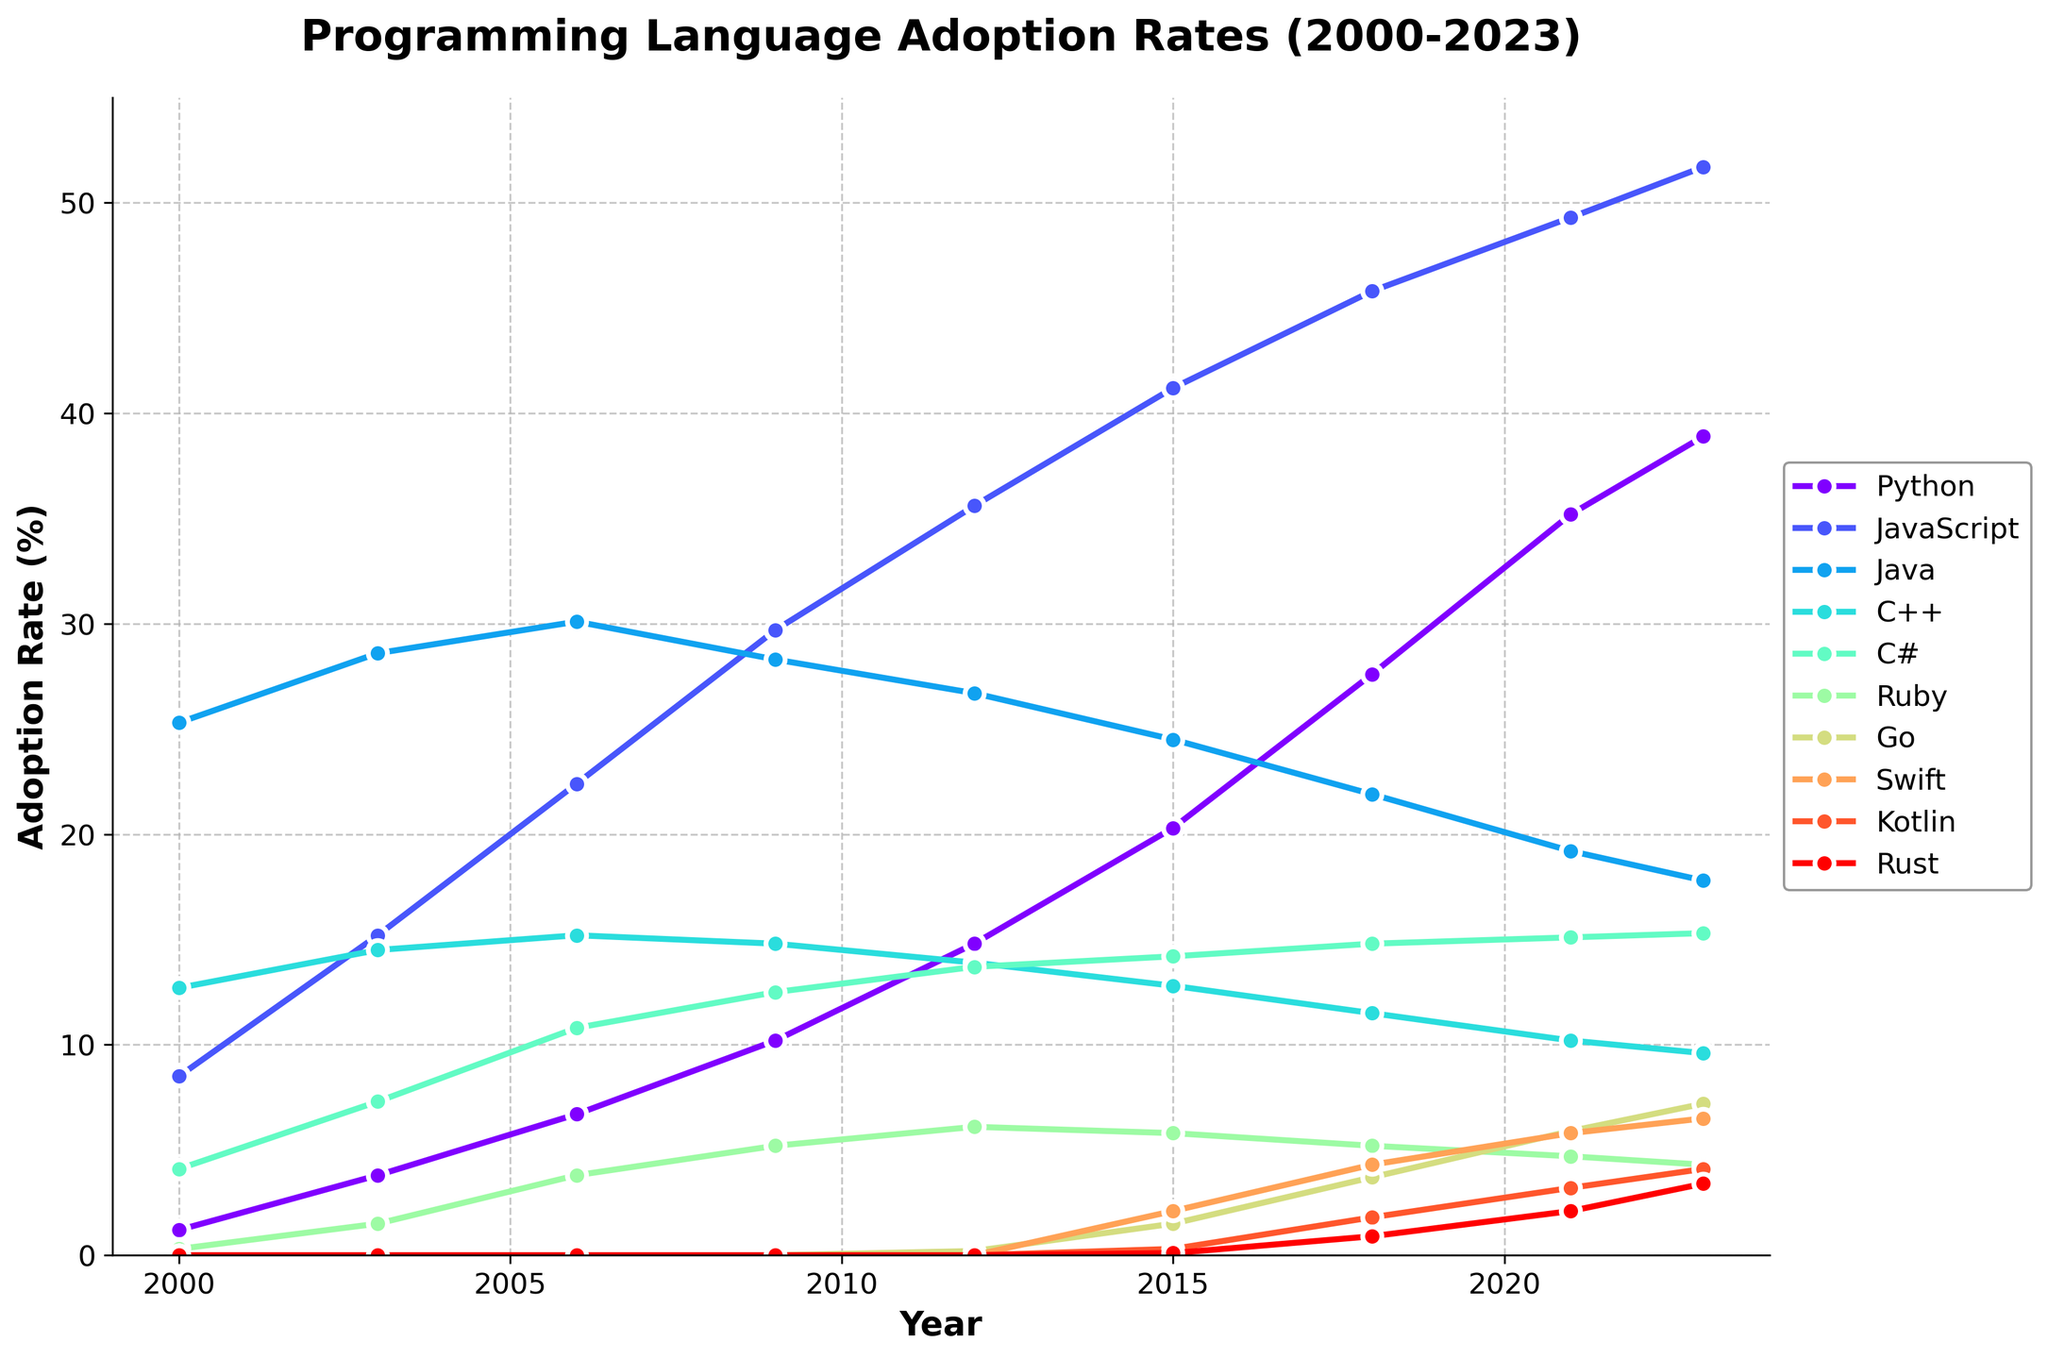What is the adoption rate of Python and JavaScript in 2023? The figure shows the adoption rates at different years. Looking specifically at the year 2023 for Python, the line intersects the y-axis at around 38.9. For JavaScript, the line intersects the y-axis at around 51.7
Answer: Python: 38.9, JavaScript: 51.7 How has the adoption rate of Java changed from 2000 to 2023? Refer to the figure at two points: 2000 and 2023. In 2000, Java adoption was approximately 25.3. By 2023, it declined to around 17.8. The difference is 25.3 - 17.8
Answer: Decreased by 7.5 Which year shows the greatest increase in Python adoption rate? By comparing the slopes of the Python line between different years, the steepest rise will indicate the greatest increase. From the visual, the largest jump occurs between 2009 and 2012 (from 10.2% to 14.8%). The increase is 14.8 - 10.2
Answer: Between 2009 and 2012 What is the trend of C++ adoption rate over the years? Observe the C++ line which starts at 12.7% in 2000, rises slightly to a peak around 2006 (15.2%), and then steadily declines to 9.6% in 2023. The overall trend shows an initial rise followed by a consistent decline
Answer: Initially increased, then steadily declined Compare the adoption rates of Swift and Kotlin in 2023. Which one is higher and by how much? In 2023, the figure shows Swift at approximately 6.5% and Kotlin at 4.1%. The difference is 6.5 - 4.1
Answer: Swift is higher by 2.4 Which programming language showed the least adoption rate in 2023? By comparing the y-values for the year 2023, Ruby has the lowest adoption rate of approximately 4.3%
Answer: Ruby with 4.3 Calculate the average adoption rate of Rust from 2000 to 2023. Rust adoption is only shown starting from 2018 (0.9%), 2021 (2.1%), and 2023 (3.4%). The average is calculated as (0.9 + 2.1 + 3.4) / 3
Answer: 2.13 How does the adoption rate of C# in 2023 compare to that in 2003? C# adoption in 2003 is about 7.3%, rising to around 15.3% in 2023. Therefore, the rate more than doubled
Answer: More than doubled Identify the programming language with the most stable adoption rate between 2000 and 2023. Reviewing the figure, C++ displays the least variance compared to others, starting at 12.7% in 2000 and going to 9.6% in 2023
Answer: C++ 